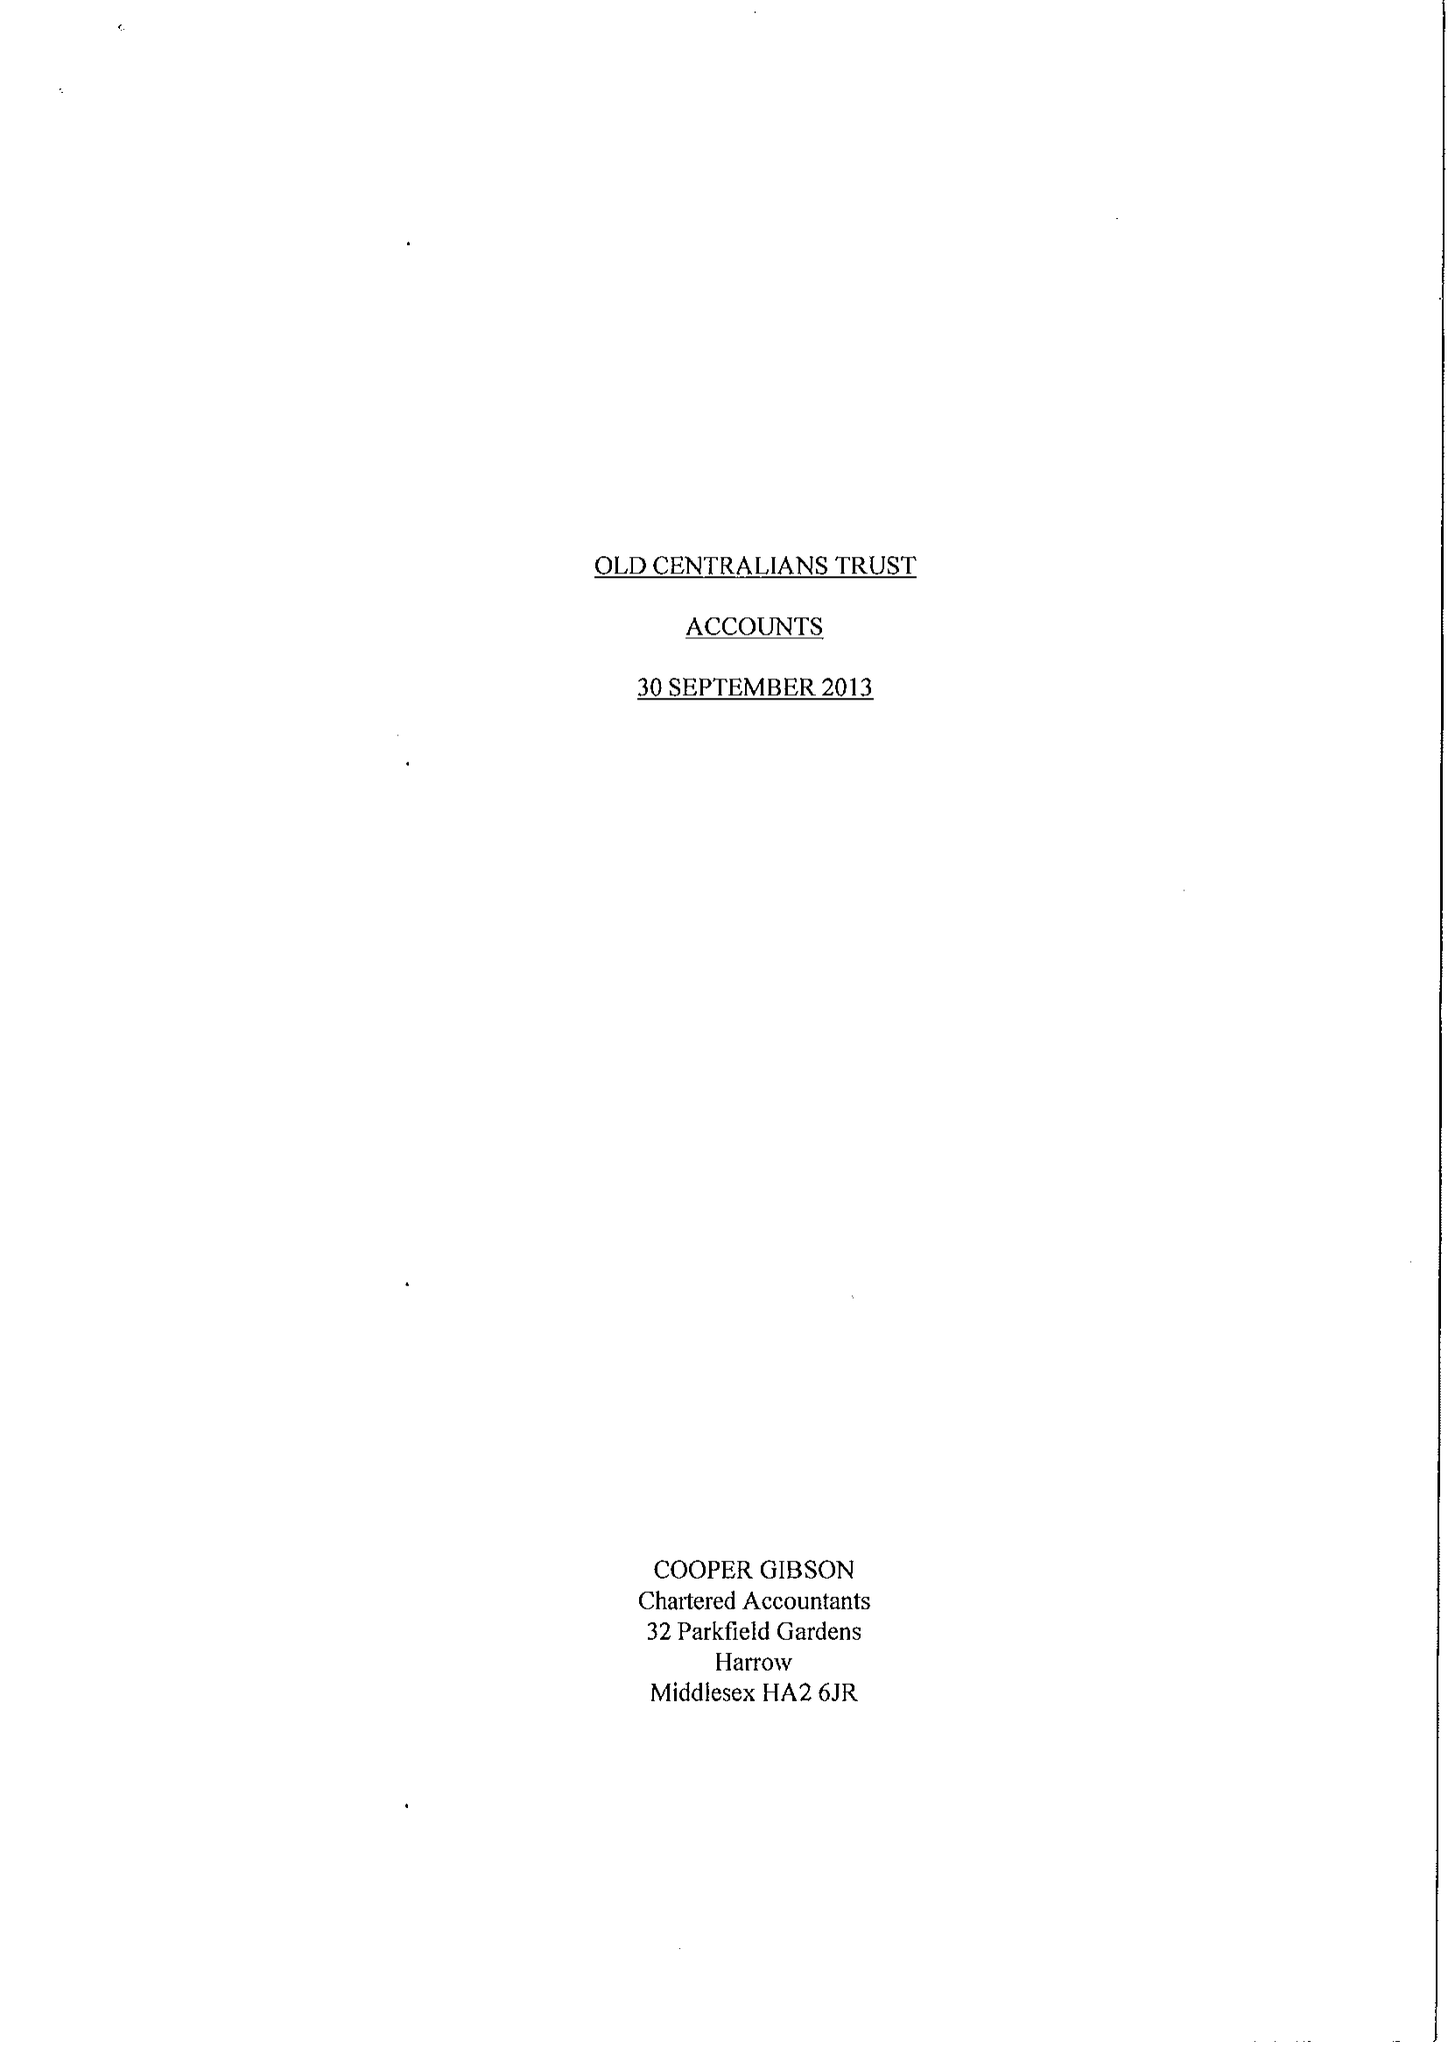What is the value for the address__street_line?
Answer the question using a single word or phrase. None 